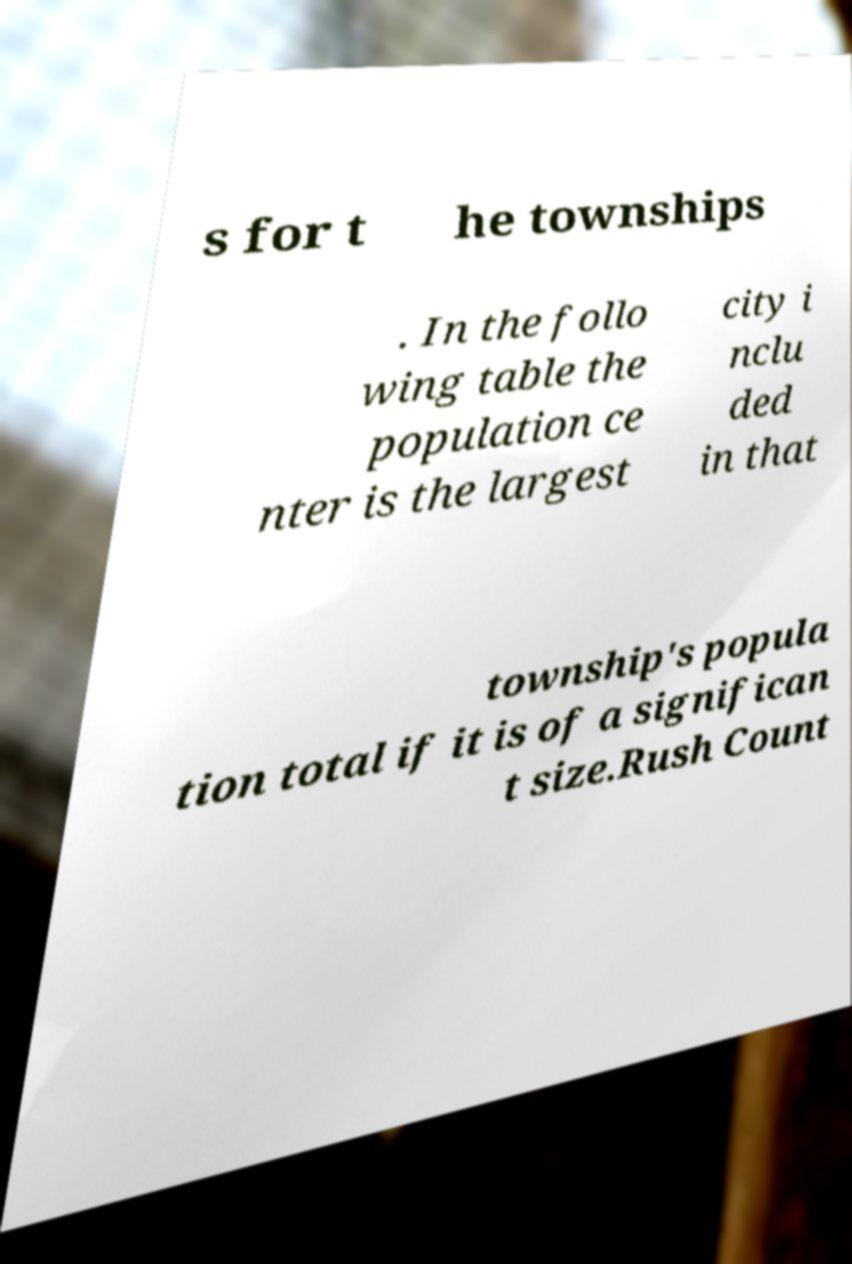For documentation purposes, I need the text within this image transcribed. Could you provide that? s for t he townships . In the follo wing table the population ce nter is the largest city i nclu ded in that township's popula tion total if it is of a significan t size.Rush Count 